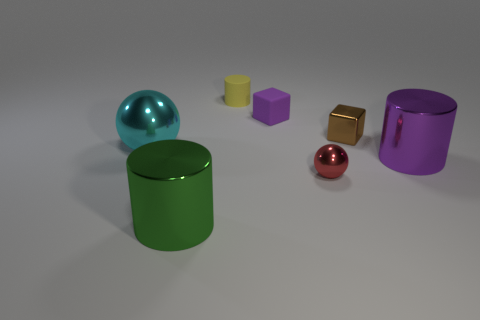How many matte objects are either small brown things or small green cylinders?
Provide a short and direct response. 0. How big is the yellow cylinder that is on the left side of the ball on the right side of the big ball?
Provide a short and direct response. Small. What material is the thing that is the same color as the matte cube?
Your response must be concise. Metal. There is a ball that is right of the shiny cylinder that is to the left of the rubber cube; is there a brown object to the left of it?
Give a very brief answer. No. Is the large cylinder on the right side of the yellow object made of the same material as the cylinder to the left of the small yellow cylinder?
Offer a terse response. Yes. How many things are cyan cylinders or tiny objects in front of the small matte cylinder?
Give a very brief answer. 3. What number of cyan things have the same shape as the purple metal object?
Ensure brevity in your answer.  0. What material is the purple object that is the same size as the yellow matte cylinder?
Keep it short and to the point. Rubber. How big is the cylinder in front of the large metal object on the right side of the cylinder in front of the big purple thing?
Ensure brevity in your answer.  Large. There is a ball that is on the right side of the cyan sphere; does it have the same color as the thing in front of the small red shiny thing?
Offer a terse response. No. 